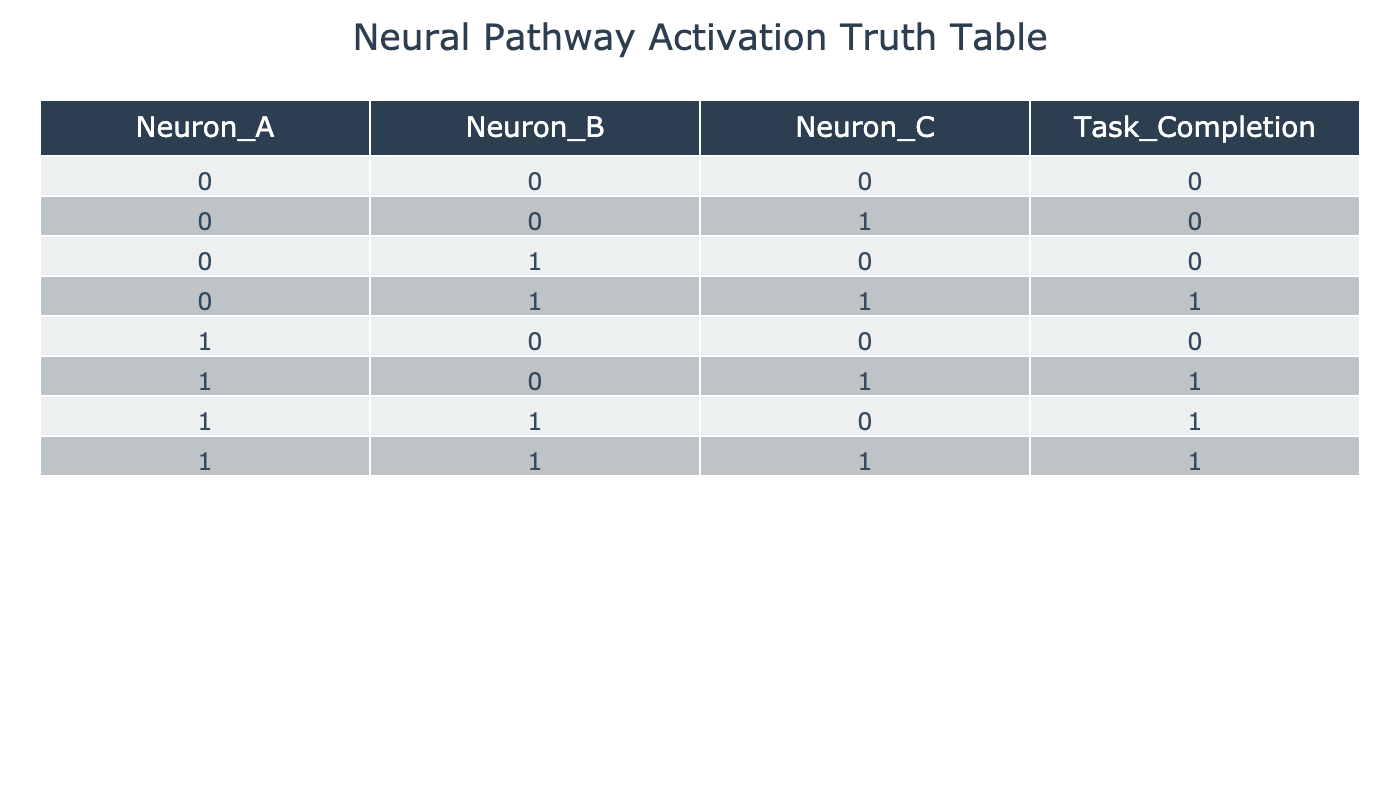What is the output for Task Completion when Neuron A, Neuron B, and Neuron C are all inactive? Referring to the table, when all three neurons are inactive (0, 0, 0), the output for Task Completion is listed as 0.
Answer: 0 What is the output for Task Completion when Neuron A is active, Neuron B is inactive, and Neuron C is active? In the table, when Neuron A is active (1), Neuron B is inactive (0), and Neuron C is active (1), the corresponding output for Task Completion is 1.
Answer: 1 How many combinations of Neuron activations lead to Task Completion being successful (1)? Checking each row for instances where Task Completion is 1, we find three rows (0, 1, 1), (1, 0, 1), (1, 1, 0), and (1, 1, 1) that yield a successful output. Thus, there are 4 successful combinations.
Answer: 4 What is the average output for Task Completion across all rows? Adding the outputs from the Task Completion column (0 + 0 + 0 + 1 + 0 + 1 + 1 + 1) gives us a sum of 4. There are 8 rows, hence the average output is 4 divided by 8, which equals 0.5.
Answer: 0.5 If Neuron A is activated, what is the probability that Task Completion will occur? From the table, whenever Neuron A is active (rows where Neuron A is 1), we have the following Task Completion outputs: (1, 0, 0, 1) indicating successes in 3 out of 5 cases. Therefore, the probability is 3/5 = 0.6.
Answer: 0.6 Are there any instances where both Neuron B and Neuron C are active, but Task Completion does not occur? Looking at the rows where Neuron B and Neuron C are both 1, we find one instance (1, 1, 0), where Task Completion is 1 and one instance (1, 1, 1) where Task Completion is 1. Thus, there are no instances where Task Completion is unsuccessful in this case.
Answer: No What is the relationship between the activation of Neuron B and Task Completion? By analyzing the rows with Neuron B activated (1), we observe that it is a determinant for successful Task Completion in the cases where it appears (1, 1, 0) and (1, 1, 1); thus, Neuron B's activation seems strongly correlated with Task Completion's success or failure.
Answer: Strong correlation 